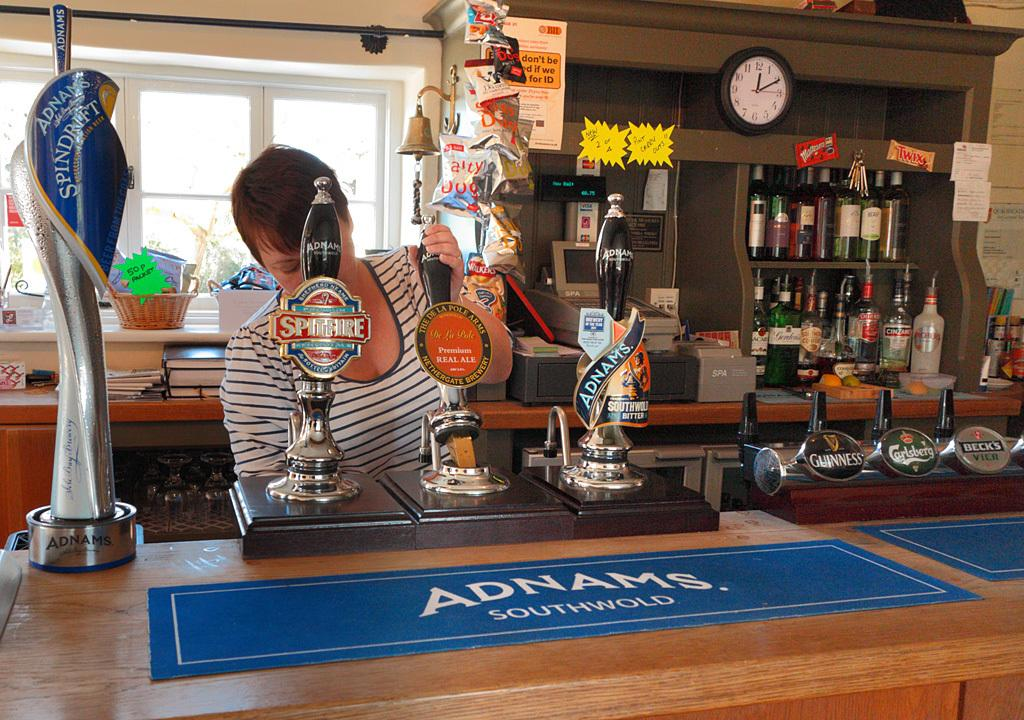<image>
Create a compact narrative representing the image presented. Adnams Spindrift on tap and also Spitfire is on tap in this pub. 